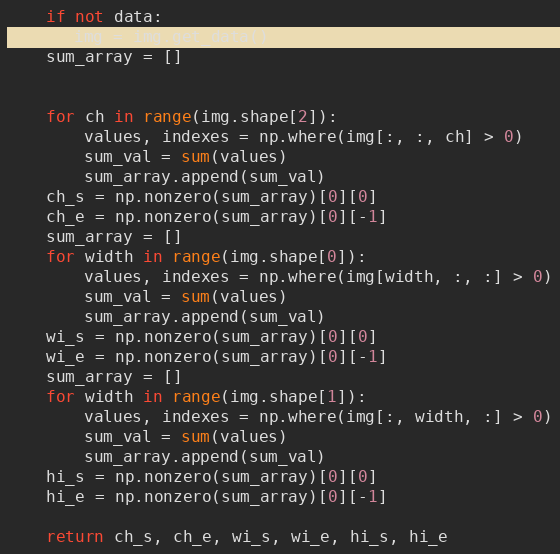<code> <loc_0><loc_0><loc_500><loc_500><_Python_>    if not data:
       img = img.get_data()
    sum_array = []


    for ch in range(img.shape[2]):
        values, indexes = np.where(img[:, :, ch] > 0)
        sum_val = sum(values)
        sum_array.append(sum_val)
    ch_s = np.nonzero(sum_array)[0][0]
    ch_e = np.nonzero(sum_array)[0][-1]
    sum_array = []
    for width in range(img.shape[0]):
        values, indexes = np.where(img[width, :, :] > 0)
        sum_val = sum(values)
        sum_array.append(sum_val)
    wi_s = np.nonzero(sum_array)[0][0]
    wi_e = np.nonzero(sum_array)[0][-1]
    sum_array = []
    for width in range(img.shape[1]):
        values, indexes = np.where(img[:, width, :] > 0)
        sum_val = sum(values)
        sum_array.append(sum_val)
    hi_s = np.nonzero(sum_array)[0][0]
    hi_e = np.nonzero(sum_array)[0][-1]

    return ch_s, ch_e, wi_s, wi_e, hi_s, hi_e</code> 